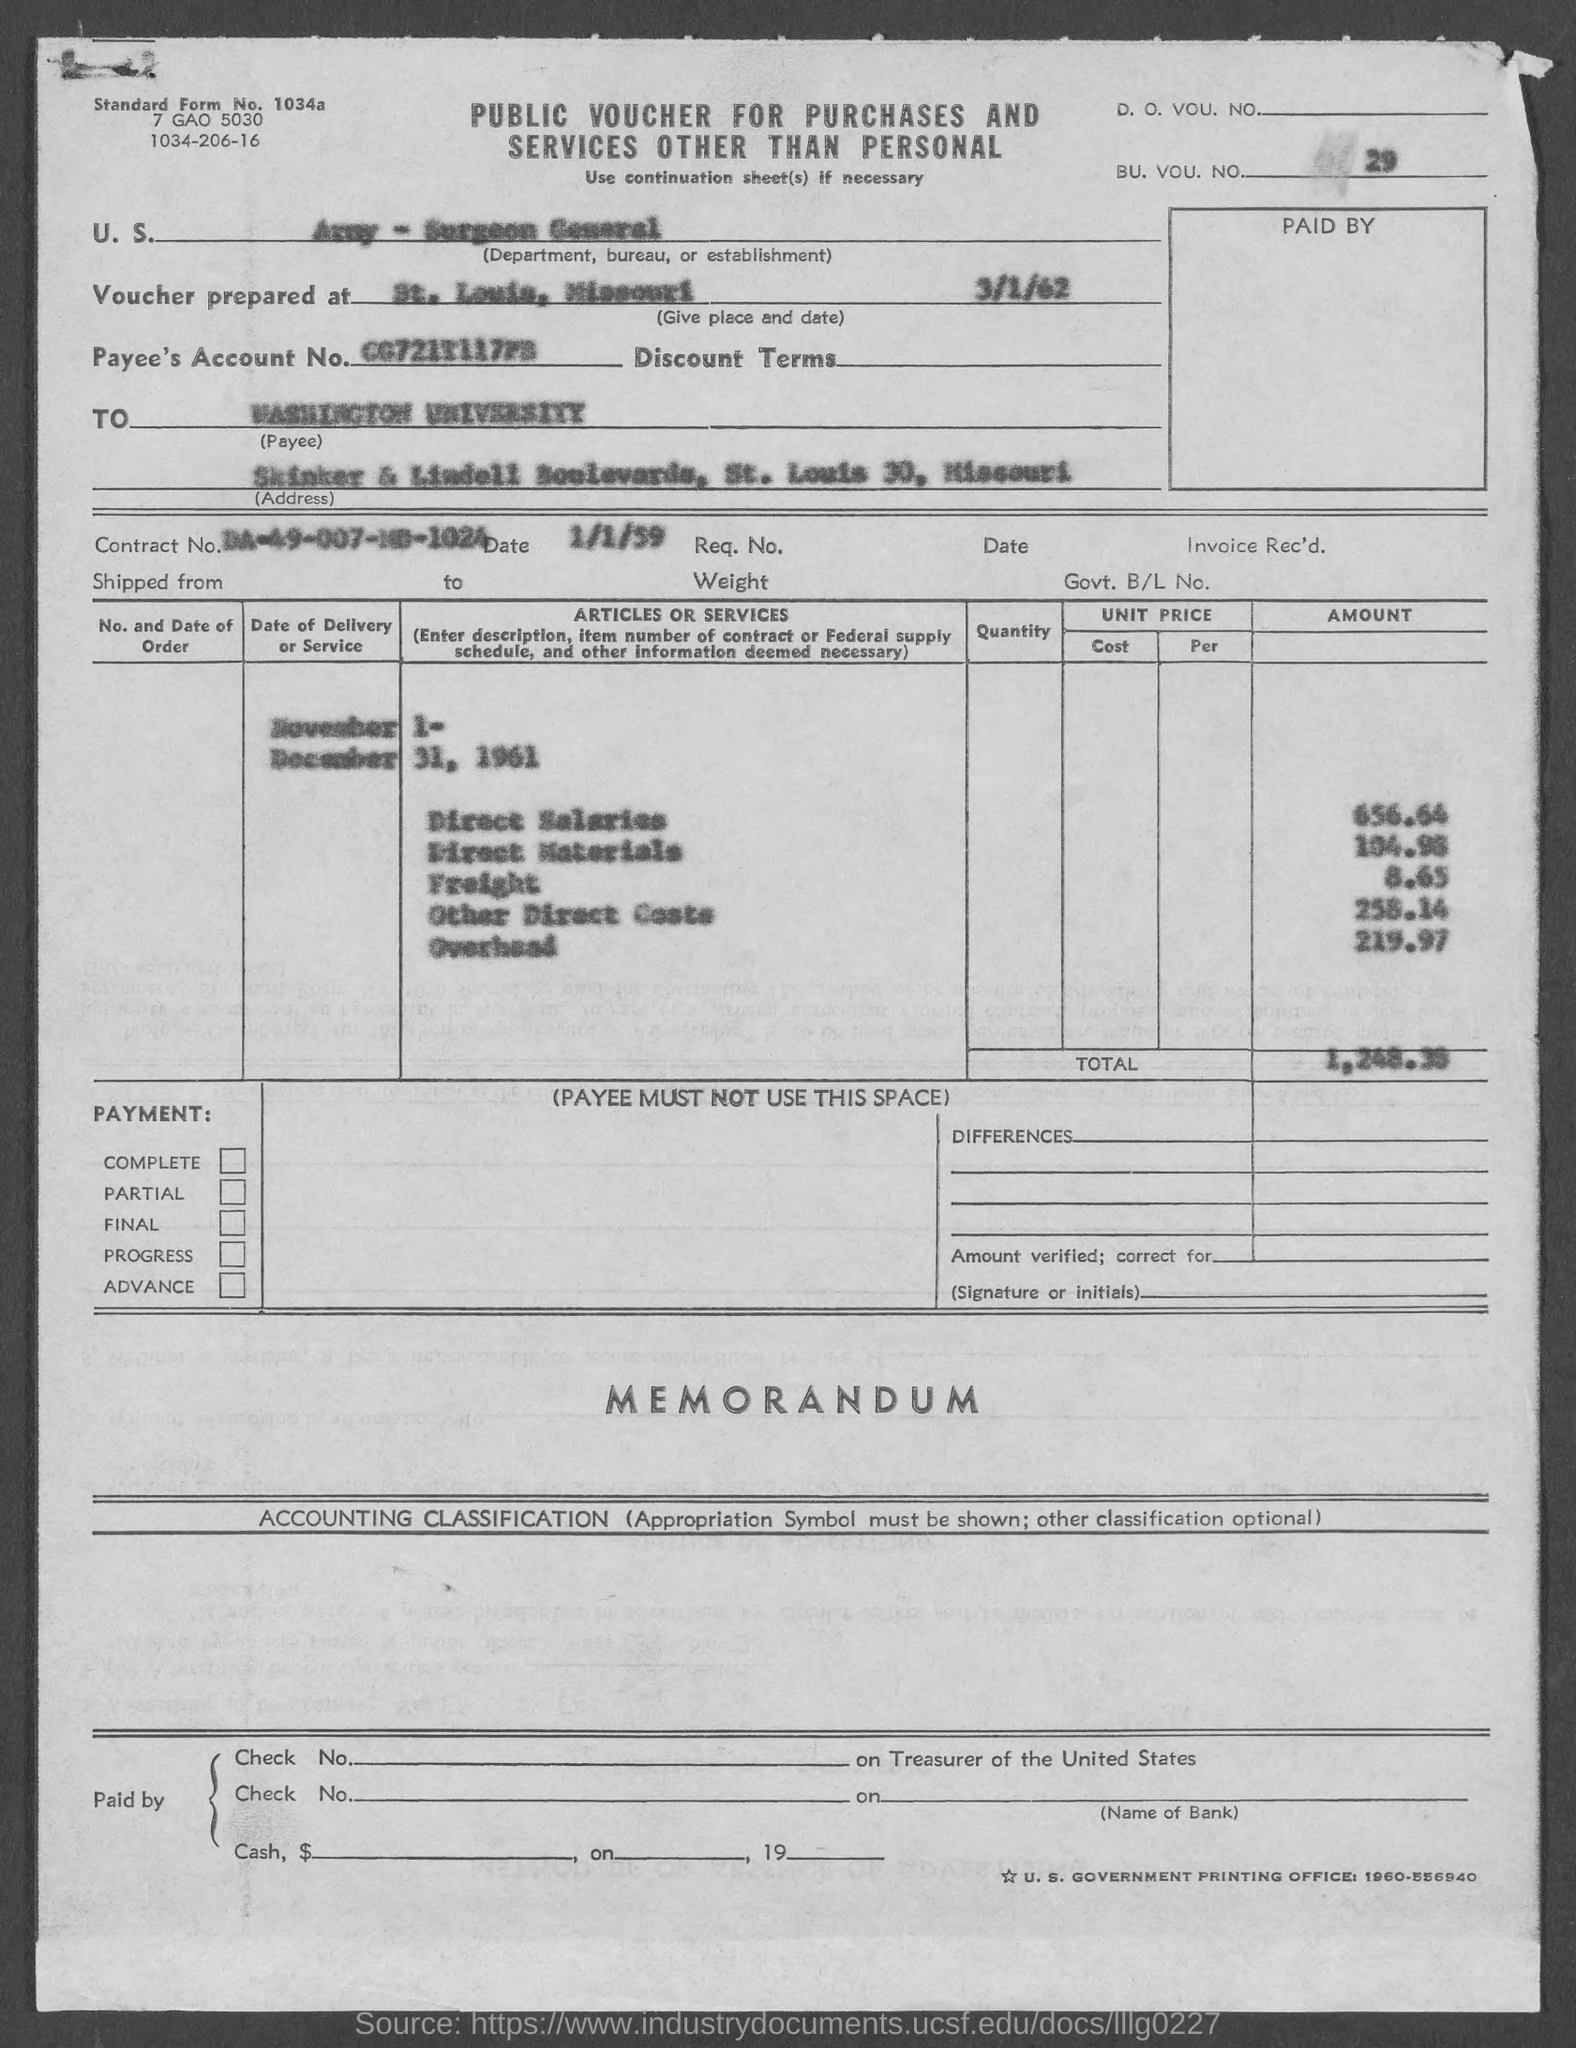What is the standard form no.?
Give a very brief answer. 1034a. What is the bu. vou. no.?
Provide a short and direct response. 29. What is the contract no.?
Keep it short and to the point. DA-49-007-MD-1024. What is the street address of washington university ?
Keep it short and to the point. Skinker & lindell boulevards, st. louis 30, missouri. What is the date beside contract no.. ?
Keep it short and to the point. 1/1/59. 